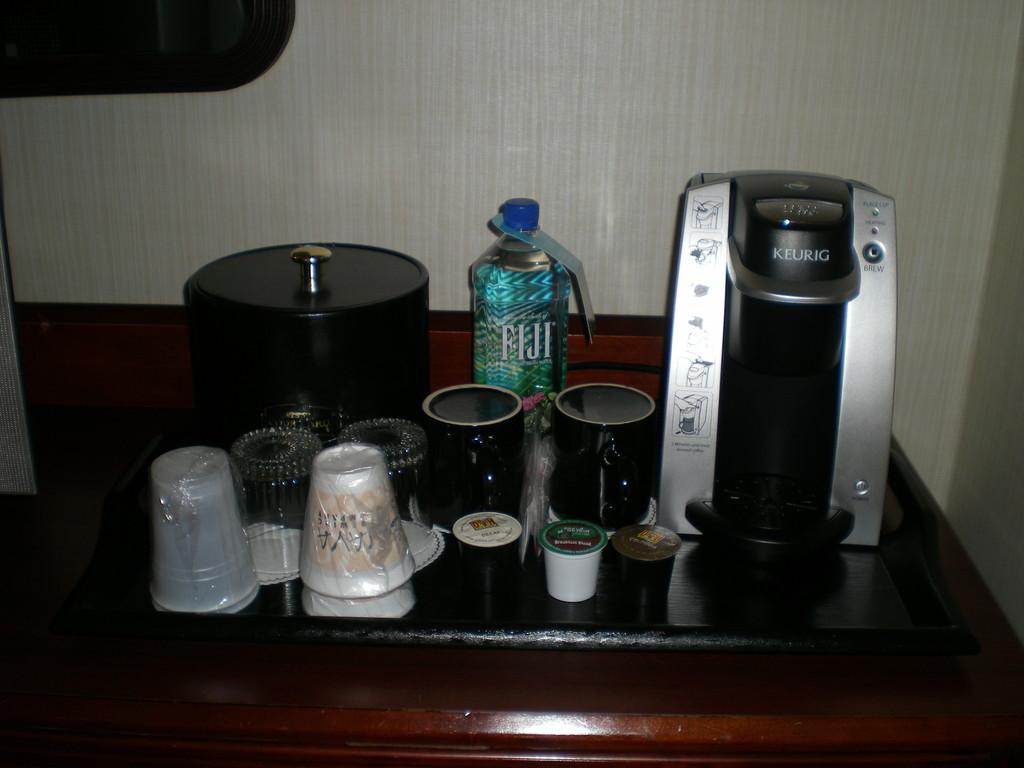<image>
Share a concise interpretation of the image provided. In a hotel room a FIJI water bottle stands on a black tray. 